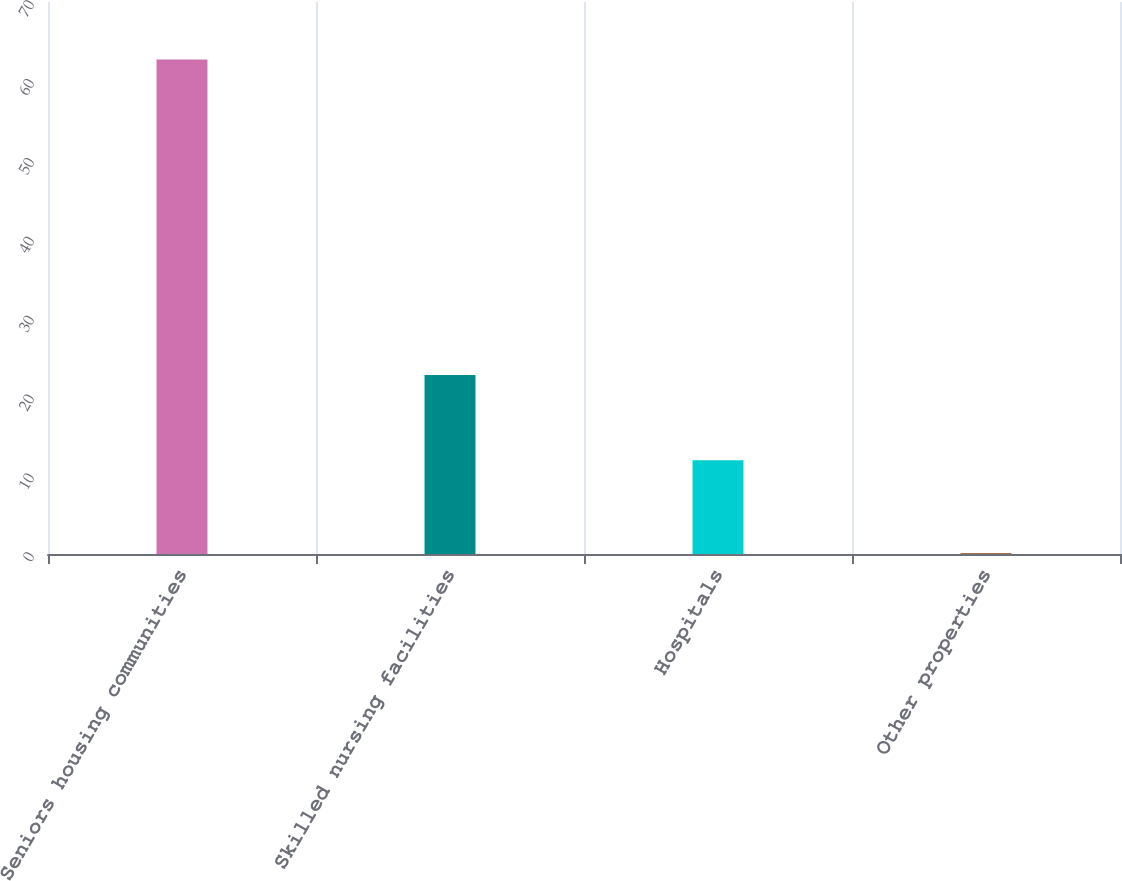<chart> <loc_0><loc_0><loc_500><loc_500><bar_chart><fcel>Seniors housing communities<fcel>Skilled nursing facilities<fcel>Hospitals<fcel>Other properties<nl><fcel>62.7<fcel>22.7<fcel>11.9<fcel>0.1<nl></chart> 